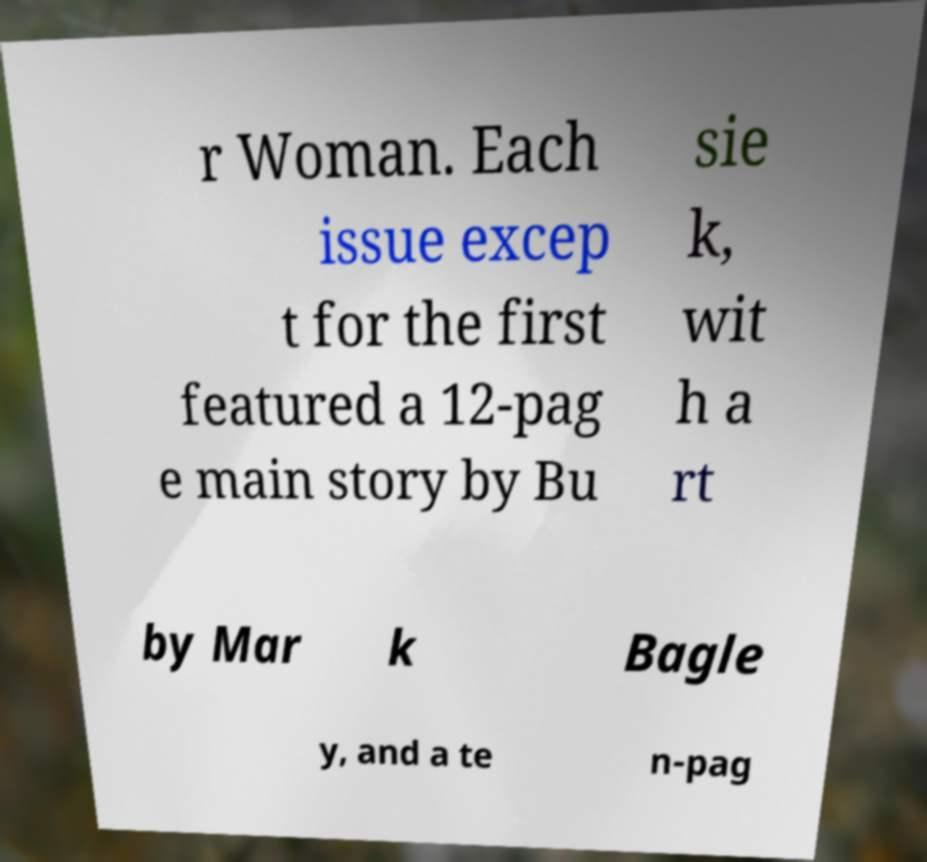Can you accurately transcribe the text from the provided image for me? r Woman. Each issue excep t for the first featured a 12-pag e main story by Bu sie k, wit h a rt by Mar k Bagle y, and a te n-pag 